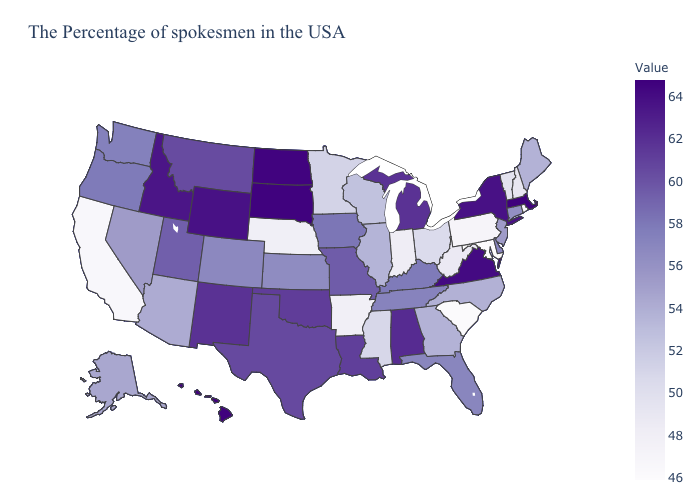Among the states that border Missouri , which have the highest value?
Keep it brief. Oklahoma. Which states have the lowest value in the West?
Answer briefly. California. Which states have the lowest value in the Northeast?
Quick response, please. Rhode Island. Among the states that border Mississippi , which have the highest value?
Concise answer only. Alabama. Among the states that border Alabama , which have the lowest value?
Answer briefly. Mississippi. Among the states that border New York , which have the highest value?
Quick response, please. Massachusetts. 